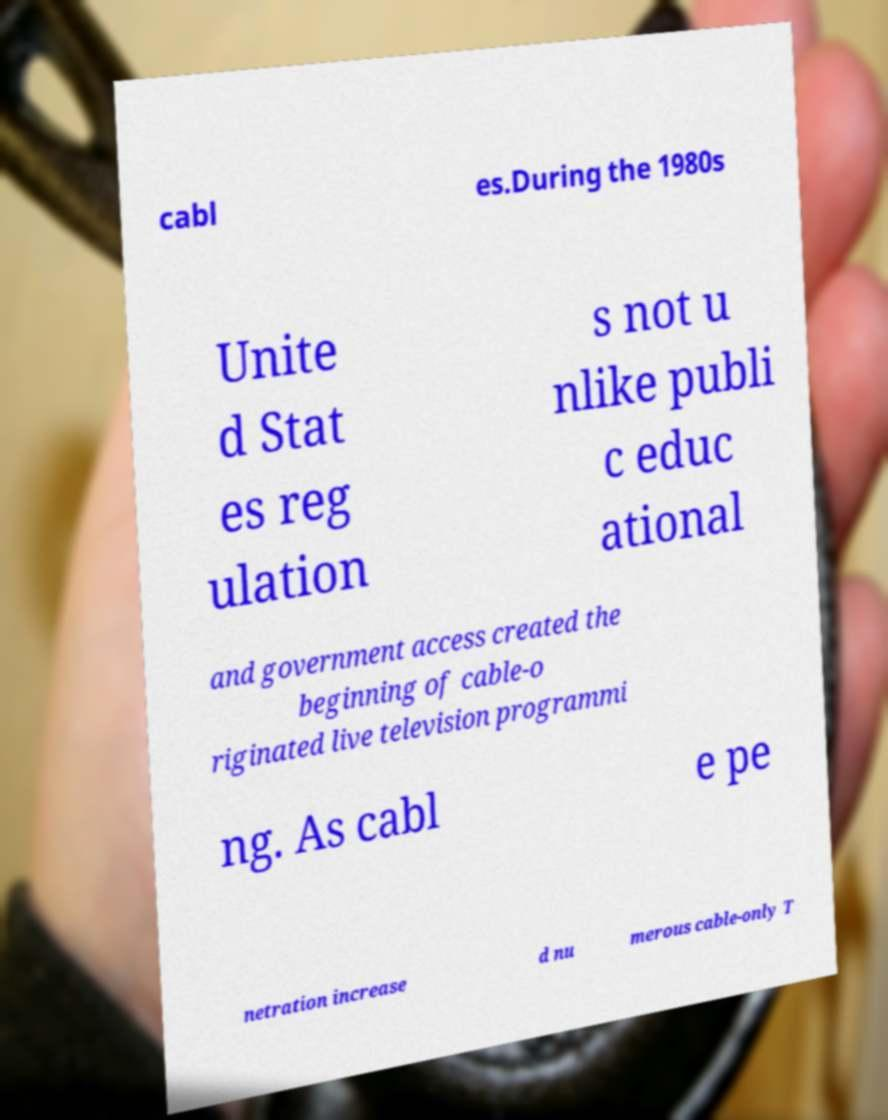There's text embedded in this image that I need extracted. Can you transcribe it verbatim? cabl es.During the 1980s Unite d Stat es reg ulation s not u nlike publi c educ ational and government access created the beginning of cable-o riginated live television programmi ng. As cabl e pe netration increase d nu merous cable-only T 